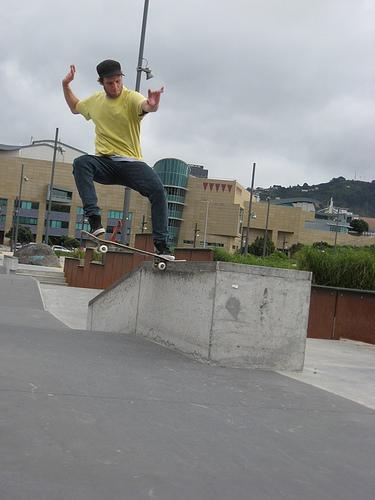What kind of trick is this skateboarder performing?

Choices:
A) tail slide
B) rail slide
C) truck grind
D) nose grind tail slide 